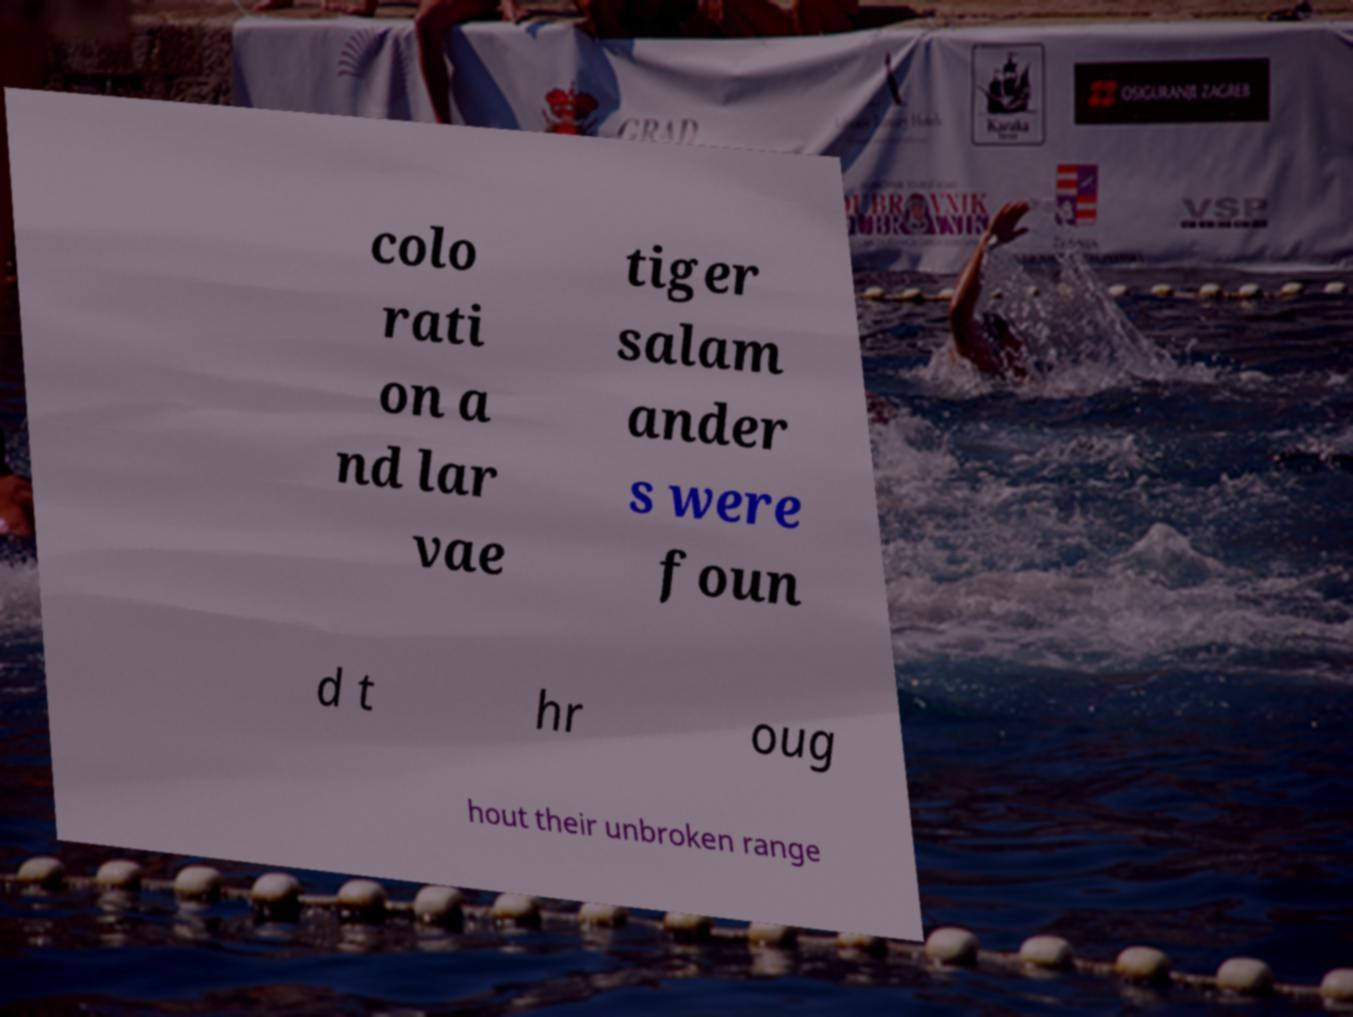Can you accurately transcribe the text from the provided image for me? colo rati on a nd lar vae tiger salam ander s were foun d t hr oug hout their unbroken range 